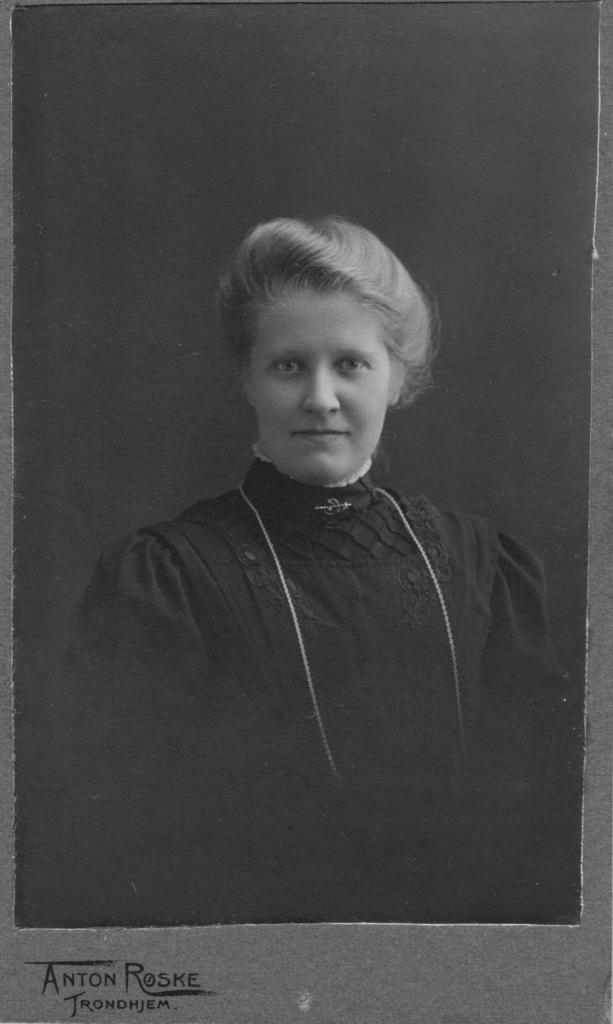Describe this image in one or two sentences. This is a black and white image. In this image we can see a woman. On the bottom of the image we can see some text. 